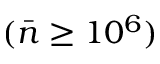<formula> <loc_0><loc_0><loc_500><loc_500>( \bar { n } \geq 1 0 ^ { 6 } )</formula> 